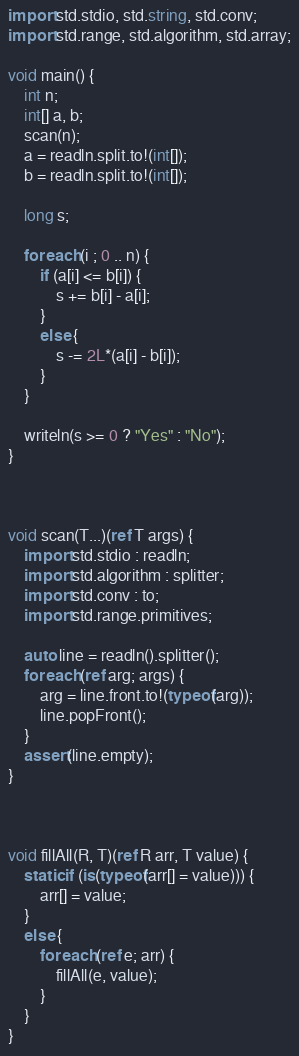Convert code to text. <code><loc_0><loc_0><loc_500><loc_500><_D_>import std.stdio, std.string, std.conv;
import std.range, std.algorithm, std.array;

void main() {
    int n;
    int[] a, b;
    scan(n);
    a = readln.split.to!(int[]);
    b = readln.split.to!(int[]);

    long s;

    foreach (i ; 0 .. n) {
        if (a[i] <= b[i]) {
            s += b[i] - a[i];
        }
        else {
            s -= 2L*(a[i] - b[i]);
        }
    }
    
    writeln(s >= 0 ? "Yes" : "No");
}



void scan(T...)(ref T args) {
    import std.stdio : readln;
    import std.algorithm : splitter;
    import std.conv : to;
    import std.range.primitives;

    auto line = readln().splitter();
    foreach (ref arg; args) {
        arg = line.front.to!(typeof(arg));
        line.popFront();
    }
    assert(line.empty);
}



void fillAll(R, T)(ref R arr, T value) {
    static if (is(typeof(arr[] = value))) {
        arr[] = value;
    }
    else {
        foreach (ref e; arr) {
            fillAll(e, value);
        }
    }
}
</code> 